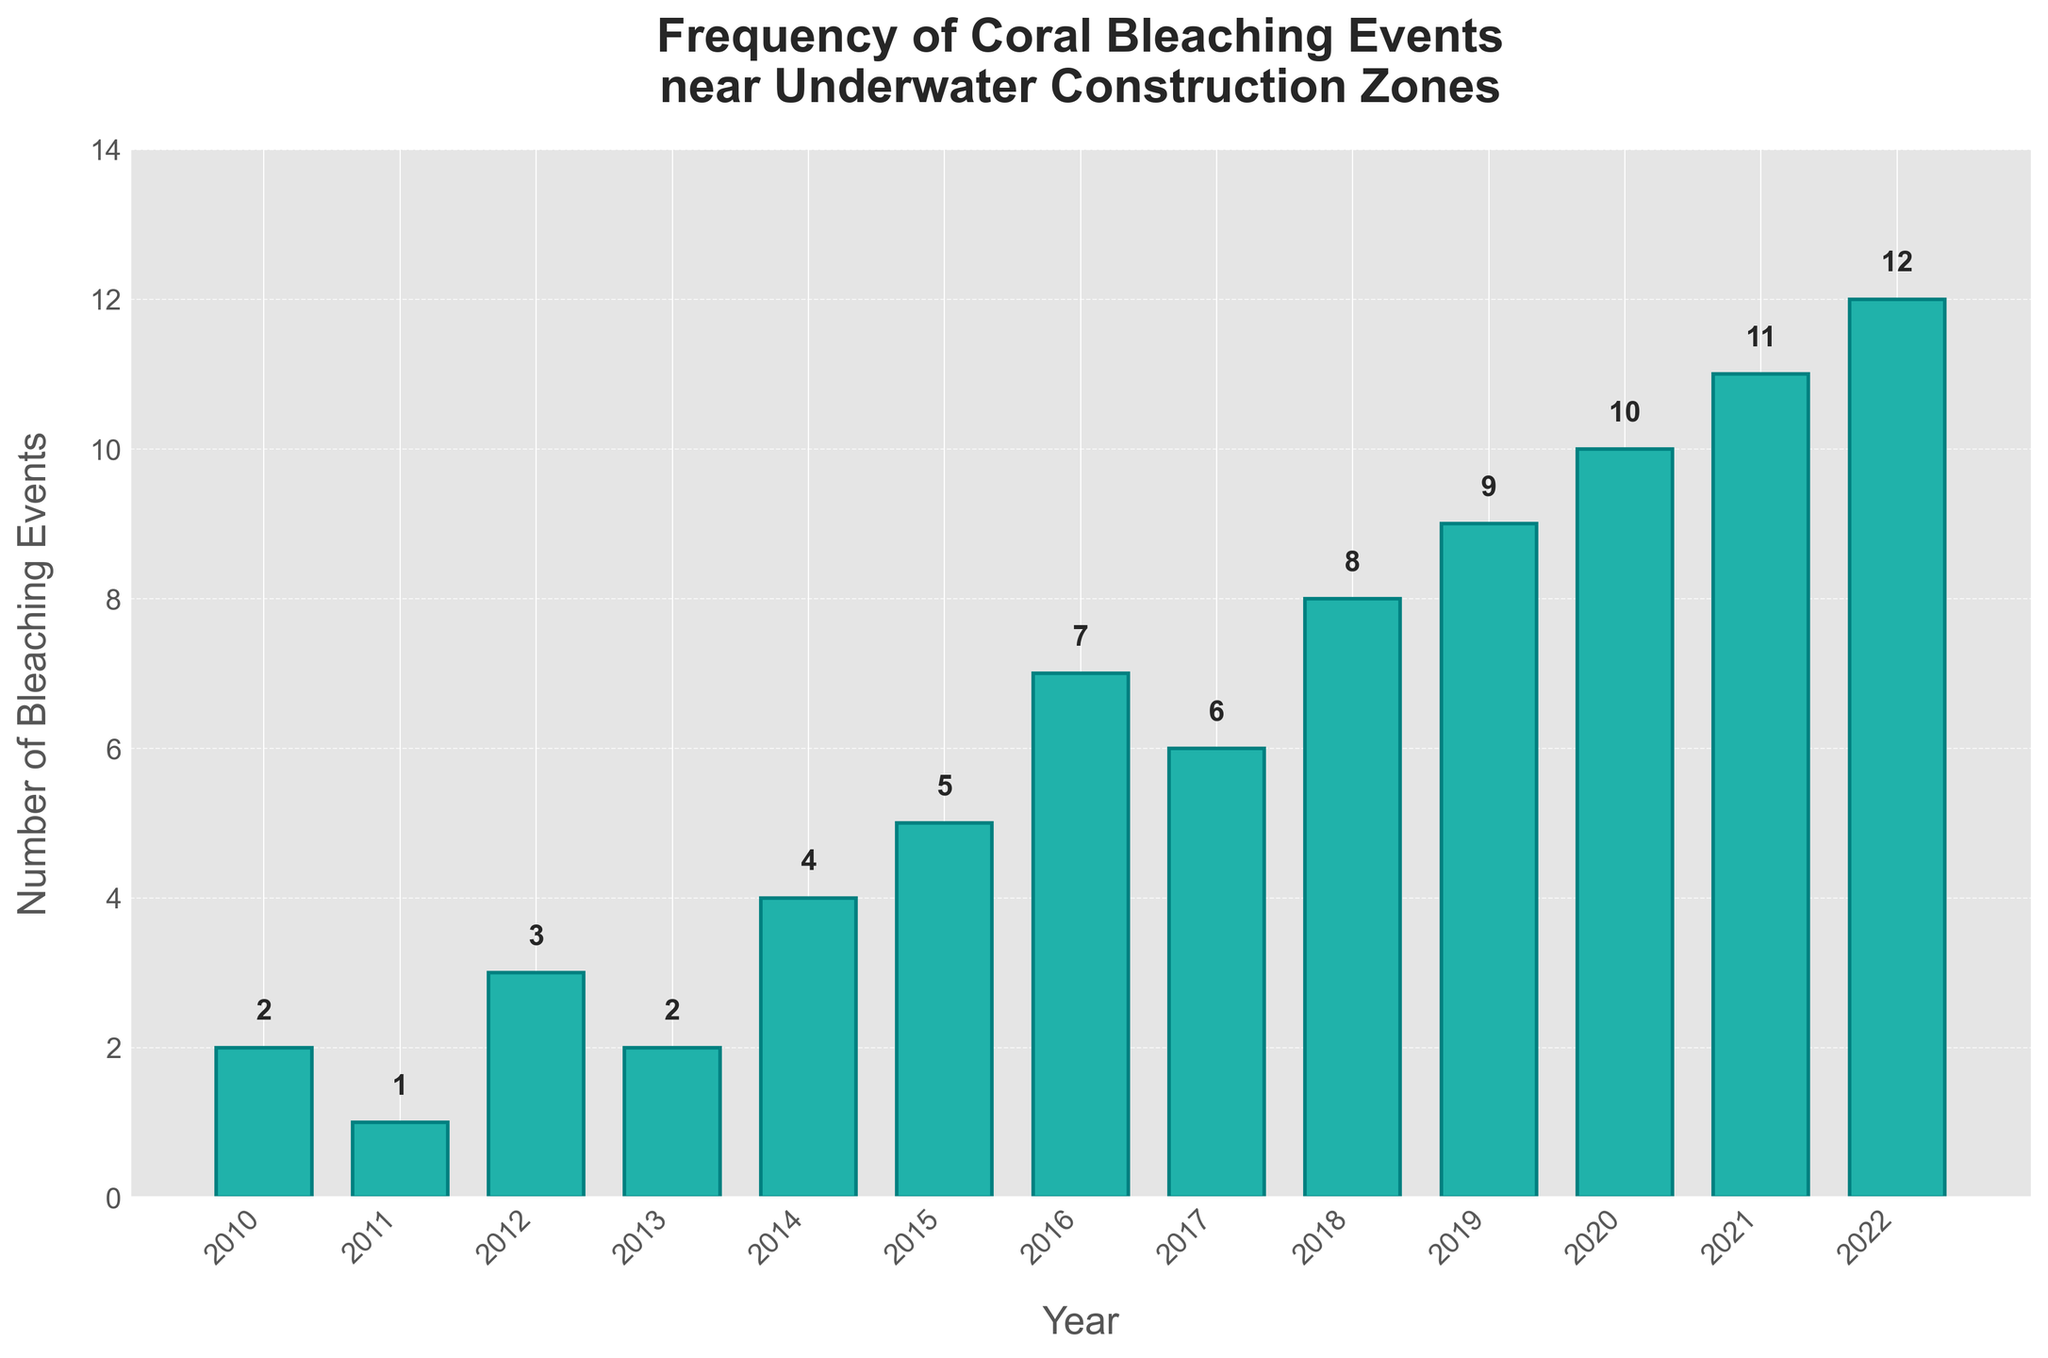What is the year with the highest number of coral bleaching events? The bar for the year 2022 is the tallest among other years, indicating the highest number of coral bleaching events.
Answer: 2022 How many coral bleaching events occurred in 2015? To find the number of bleaching events for 2015, locate the height of the bar corresponding to this year and read the value labeled above the bar, which is 5.
Answer: 5 What is the total number of bleaching events recorded from 2010 to 2015? To find the total, sum the values from 2010 (2), 2011 (1), 2012 (3), 2013 (2), 2014 (4), and 2015 (5). The sum is 2 + 1 + 3 + 2 + 4 + 5 = 17.
Answer: 17 Which year saw a decrease in the number of coral bleaching events compared to the previous year? To determine the year with a decrease, look for a year where the bar height is shorter than the previous year. The bar height in 2011 (1) is shorter than in 2010 (2).
Answer: 2011 What is the trend in coral bleaching events from 2010 to 2022? Observing the bar heights from 2010 to 2022, they show a generally increasing trend, with occasional small decreases, indicating a rise in the number of coral bleaching events over these years.
Answer: Increasing trend What is the average number of coral bleaching events per year between 2010 and 2022? Sum the bleaching events from all years and divide by the number of years: (2 + 1 + 3 + 2 + 4 + 5 + 7 + 6 + 8 + 9 + 10 + 11 + 12) / 13 = 80 / 13 ≈ 6.15.
Answer: 6.15 By how much did the number of bleaching events increase from 2010 to 2022? Subtract the number of bleaching events in 2010 from the number in 2022: 12 - 2 = 10.
Answer: 10 In which year did the first significant rise in coral bleaching events occur? Find the year with the first noticeable increase in bar height compared to the previous year. Between 2013 (2) and 2014 (4), the number of events doubled, marking the first significant rise.
Answer: 2014 What is the median number of bleaching events from 2010 to 2022? List the bleaching events in ascending order: 1, 2, 2, 3, 4, 5, 6, 7, 8, 9, 10, 11, 12. The median is the middle value, which is the 7th value: 6.
Answer: 6 Which years have the same number of coral bleaching events? Identify years with bars of equal height. 2010 and 2013 both have 2 events, and 2011 and 2012 have 1 and 3 events respectively, indicating identical numbers.
Answer: 2010 and 2013 